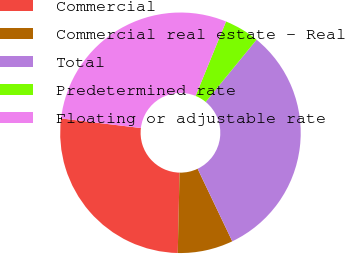Convert chart. <chart><loc_0><loc_0><loc_500><loc_500><pie_chart><fcel>Commercial<fcel>Commercial real estate - Real<fcel>Total<fcel>Predetermined rate<fcel>Floating or adjustable rate<nl><fcel>26.55%<fcel>7.45%<fcel>32.0%<fcel>4.72%<fcel>29.28%<nl></chart> 